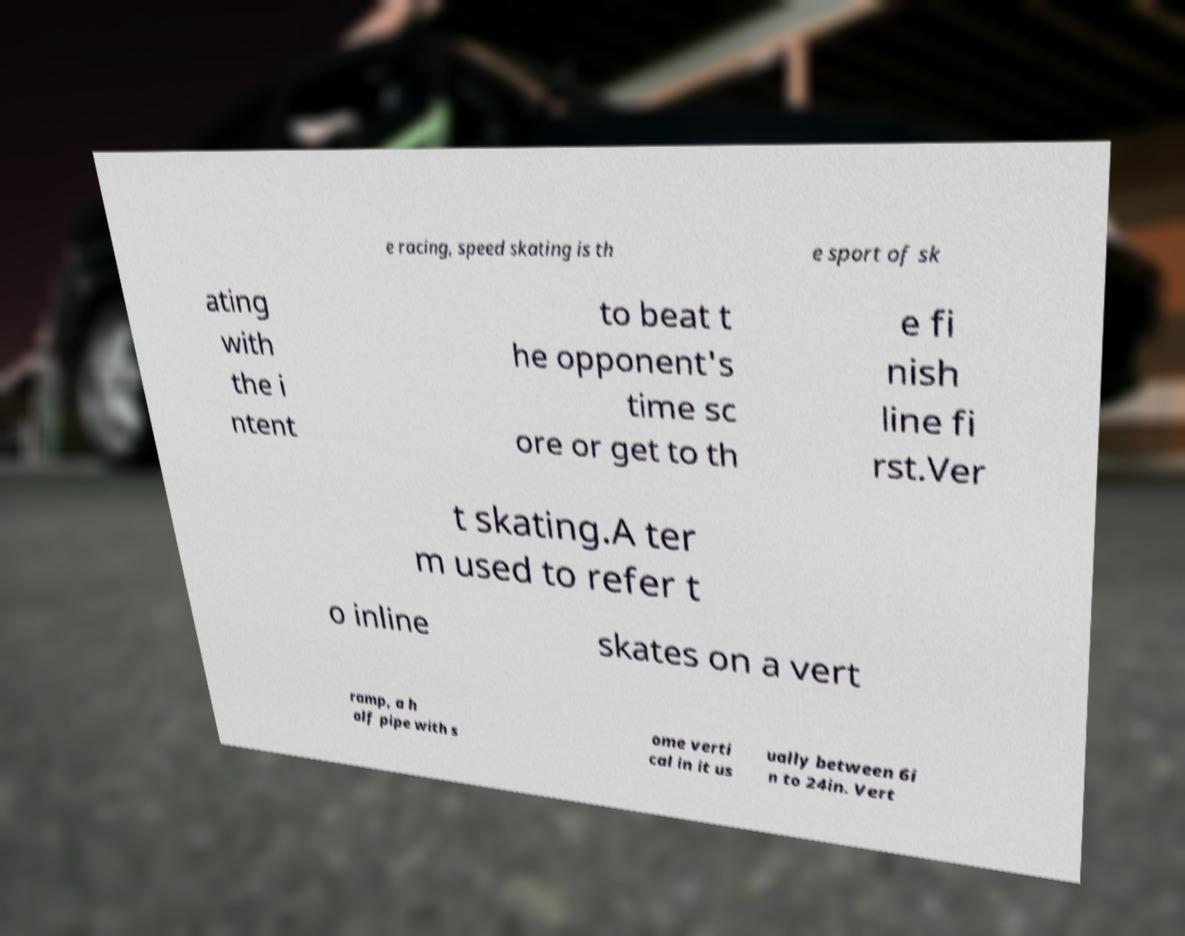I need the written content from this picture converted into text. Can you do that? e racing, speed skating is th e sport of sk ating with the i ntent to beat t he opponent's time sc ore or get to th e fi nish line fi rst.Ver t skating.A ter m used to refer t o inline skates on a vert ramp, a h alf pipe with s ome verti cal in it us ually between 6i n to 24in. Vert 